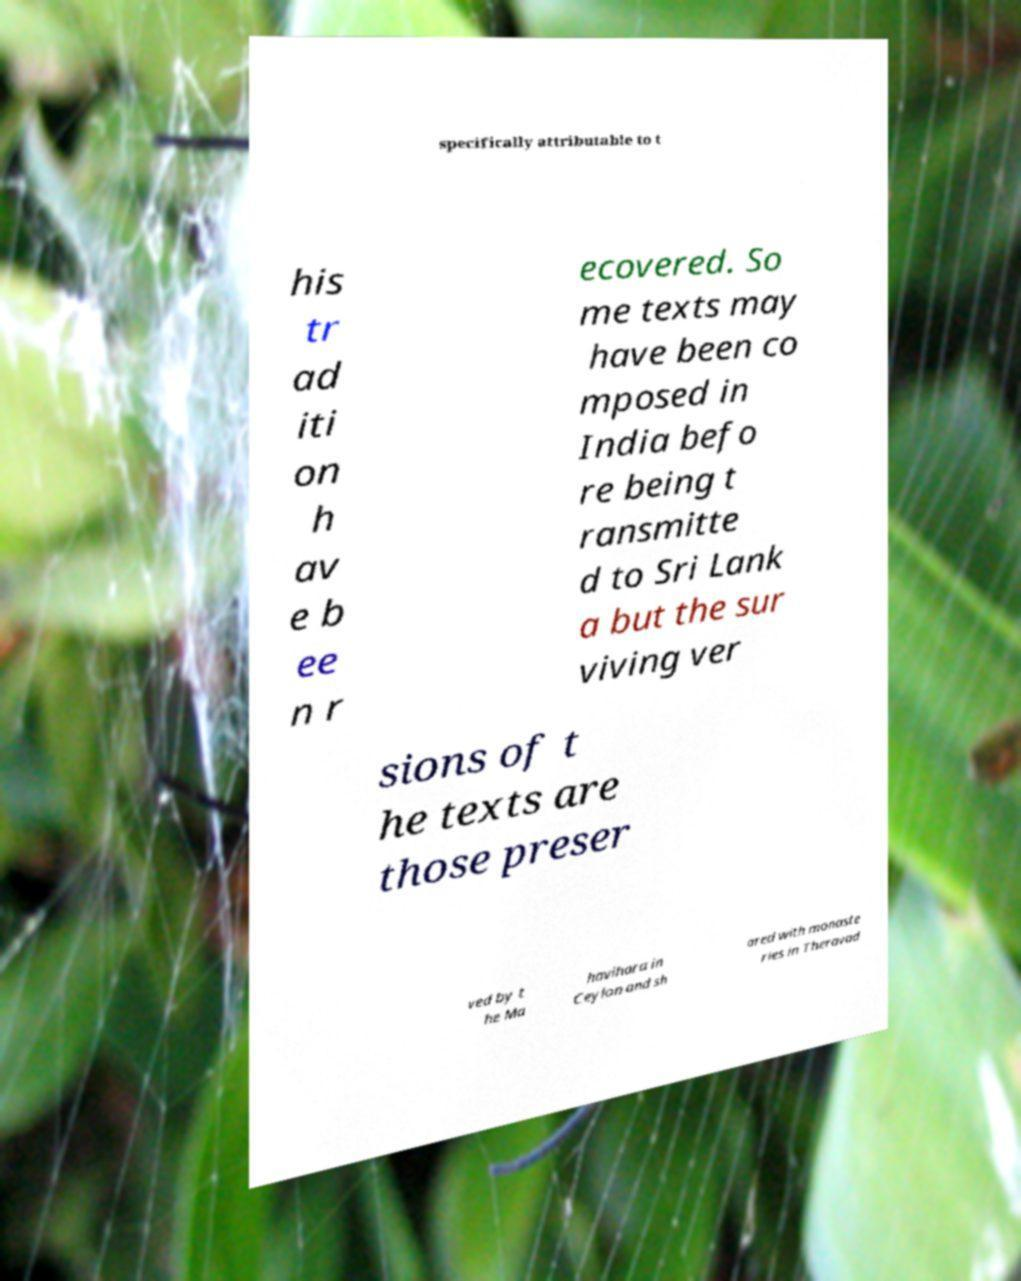Can you accurately transcribe the text from the provided image for me? specifically attributable to t his tr ad iti on h av e b ee n r ecovered. So me texts may have been co mposed in India befo re being t ransmitte d to Sri Lank a but the sur viving ver sions of t he texts are those preser ved by t he Ma havihara in Ceylon and sh ared with monaste ries in Theravad 